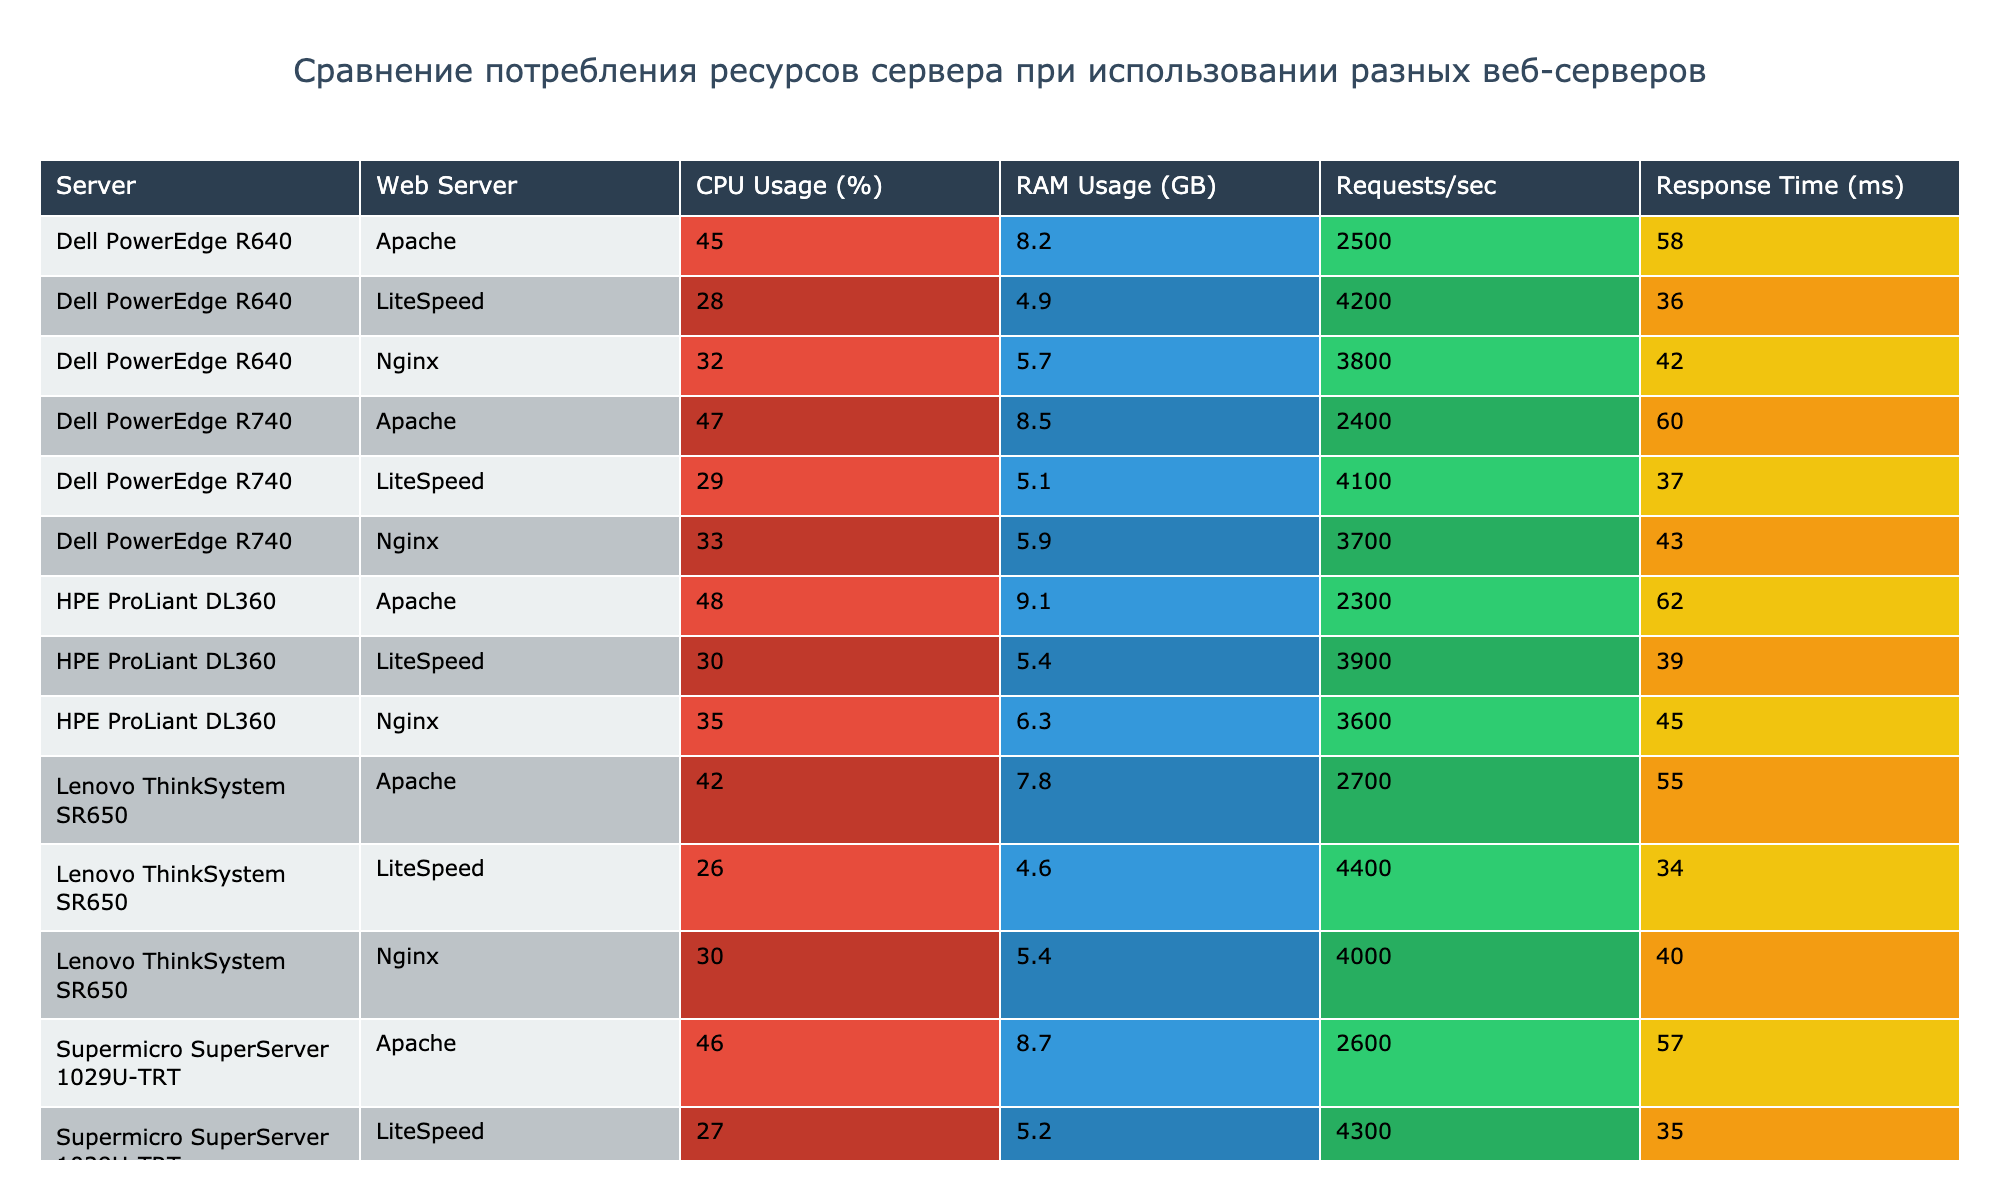What is the CPU usage percentage of Nginx on the Dell PowerEdge R640? The table shows that the CPU usage percentage for Nginx on the Dell PowerEdge R640 is 32%.
Answer: 32% Which web server has the lowest RAM usage across all servers? By comparing the RAM usage values for Apache, Nginx, and LiteSpeed across all servers, LiteSpeed on Lenovo ThinkSystem SR650 has the lowest RAM usage of 4.6 GB.
Answer: 4.6 GB What is the difference in requests per second between LiteSpeed and Apache on the Dell PowerEdge R740? The requests per second for LiteSpeed on Dell PowerEdge R740 is 4100, whereas for Apache it is 2400. Thus, the difference is 4100 - 2400 = 1700 requests/sec.
Answer: 1700 requests/sec Is the response time of Apache on the HPE ProLiant DL360 longer than that of Nginx on the same server? The response time for Apache on HPE ProLiant DL360 is 62 ms and for Nginx, it is 45 ms. Since 62 ms > 45 ms, the answer is yes.
Answer: Yes On the Lenovo ThinkSystem SR650, which web server offers the best performance in terms of both requests per second and response time? LiteSpeed on Lenovo ThinkSystem SR650 offers 4400 requests/sec and a response time of 34 ms, which is higher in requests/sec and lower in response time compared to both Apache (2700 requests/sec, 55 ms) and Nginx (4000 requests/sec, 40 ms). Therefore, LiteSpeed is the best performer.
Answer: LiteSpeed What is the average CPU usage percentage across all servers for Nginx? To calculate the average, we take the Nginx CPU usage values: 32, 35, 30, 33, and 31, sum them up (32 + 35 + 30 + 33 + 31 = 161) and divide by the number of servers (5). Thus, the average is 161 / 5 = 32.2%.
Answer: 32.2% Which web server has the maximum requests per second on the Supermicro SuperServer 1029U-TRT? The table reveals that LiteSpeed has the maximum requests per second on the Supermicro SuperServer 1029U-TRT with a value of 4300.
Answer: LiteSpeed Is it true that RAM usage is higher for Apache compared to Nginx on all servers listed? By checking the RAM usage for Apache and Nginx across all servers, Apache uses 8.2, 9.1, 7.8, 8.5, and 8.7 GB while Nginx uses 5.7, 6.3, 5.4, 5.9, and 6.1 GB, confirming that Apache indeed has higher RAM usage than Nginx on every server.
Answer: Yes What is the sum of CPU usage percentages for LiteSpeed across all servers? The sum of the CPU usage percentages for LiteSpeed is 28 + 30 + 26 + 29 + 27 = 140%.
Answer: 140% How does the response time of Nginx compare with LiteSpeed on the HPE ProLiant DL360? The response time for Nginx on HPE ProLiant DL360 is 45 ms, while LiteSpeed's response time is 39 ms. Hence, LiteSpeed has a lower response time than Nginx.
Answer: LiteSpeed has a lower response time 